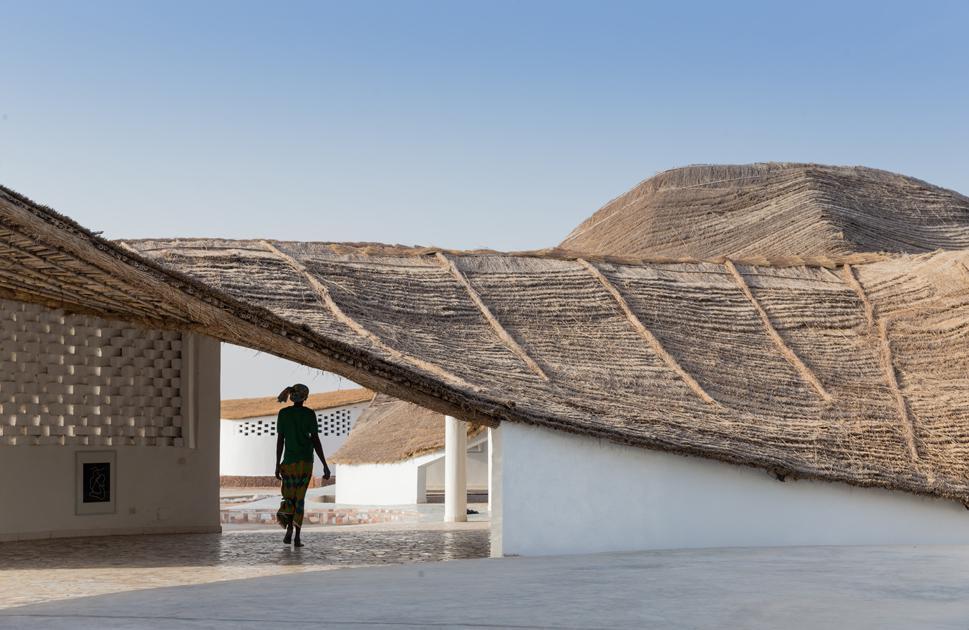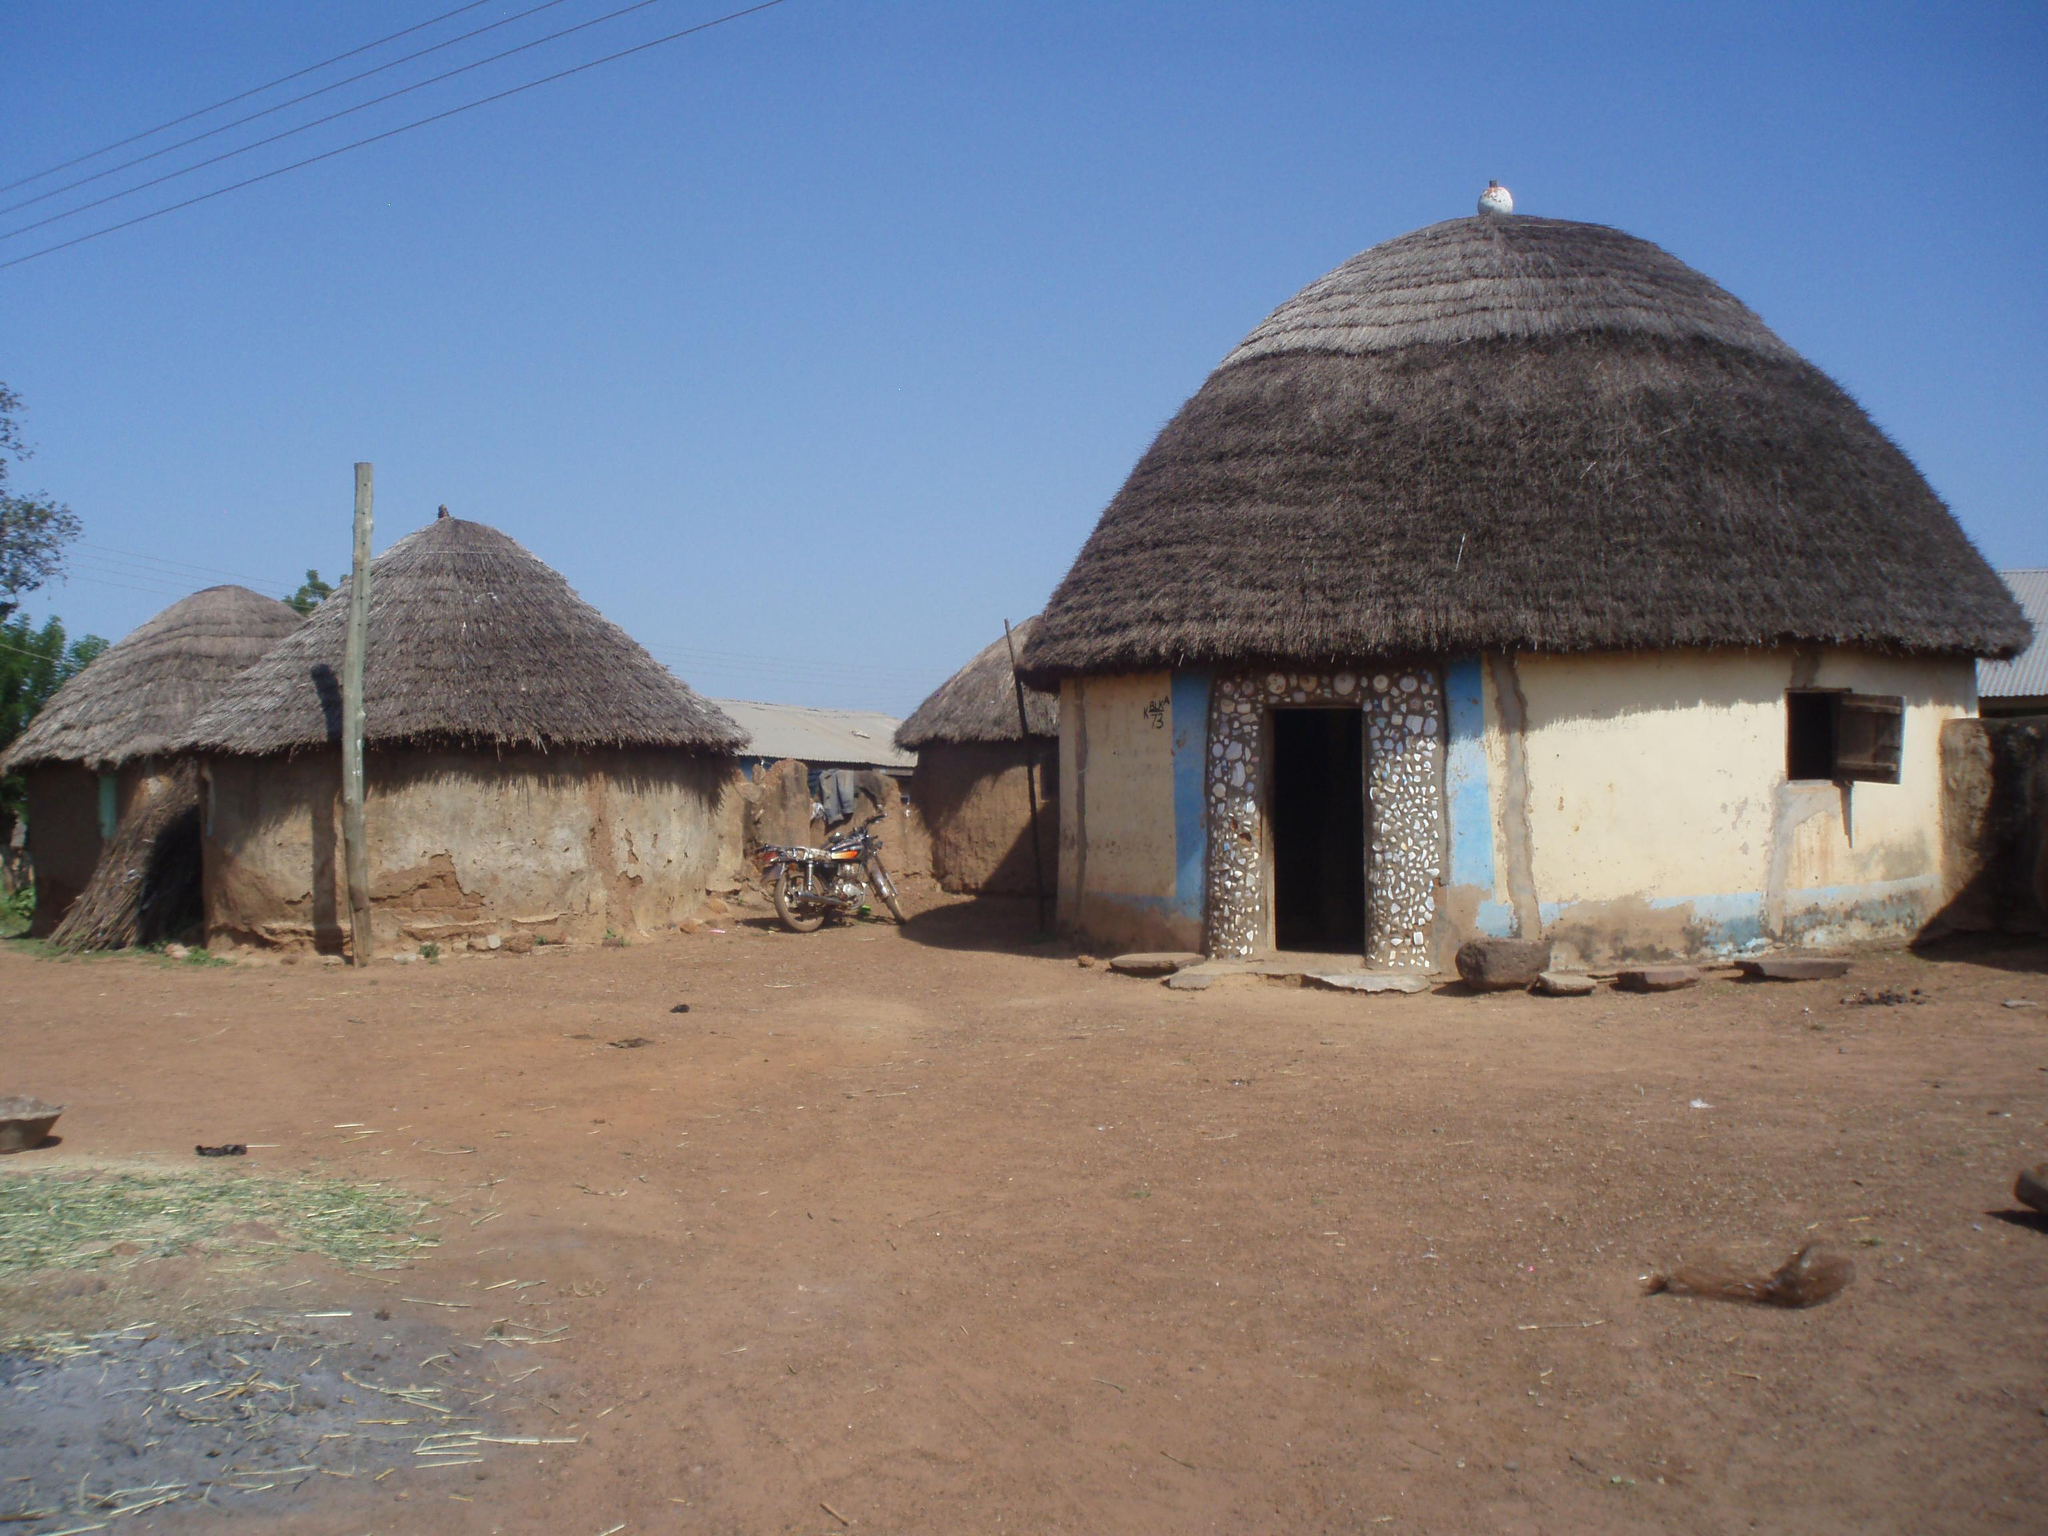The first image is the image on the left, the second image is the image on the right. Analyze the images presented: Is the assertion "The right image shows several low round buildings with cone-shaped roofs in an area with brown dirt instead of grass." valid? Answer yes or no. Yes. The first image is the image on the left, the second image is the image on the right. For the images shown, is this caption "A person is standing outside near a building in one of the images." true? Answer yes or no. Yes. 